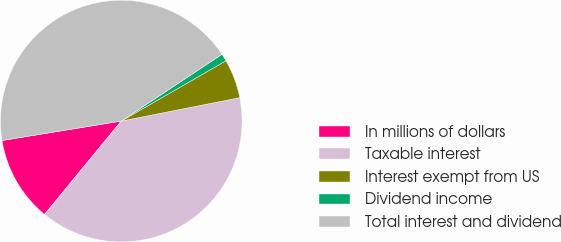Convert chart to OTSL. <chart><loc_0><loc_0><loc_500><loc_500><pie_chart><fcel>In millions of dollars<fcel>Taxable interest<fcel>Interest exempt from US<fcel>Dividend income<fcel>Total interest and dividend<nl><fcel>11.48%<fcel>39.05%<fcel>5.21%<fcel>1.0%<fcel>43.26%<nl></chart> 